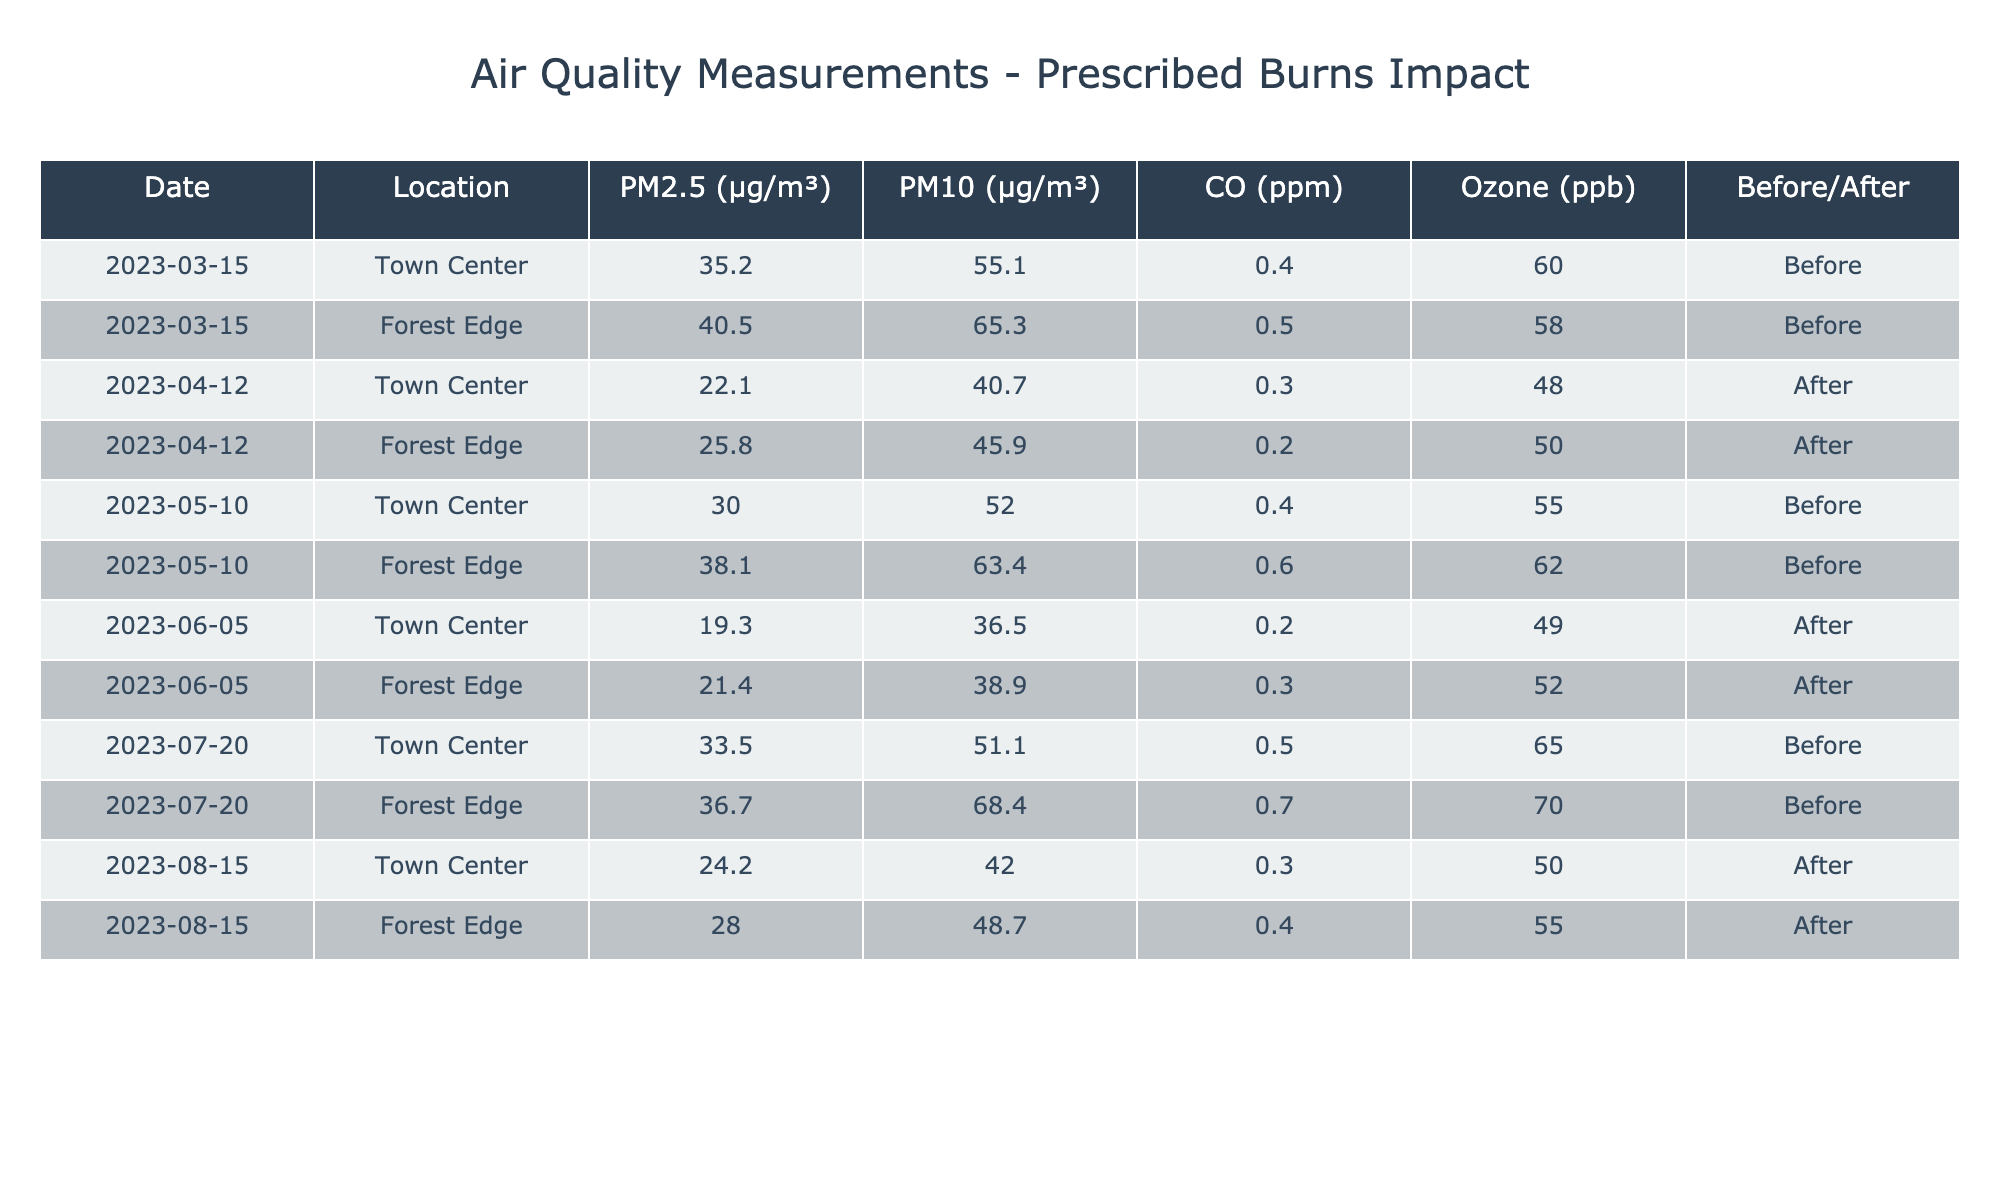What were the PM2.5 levels at Town Center before the first prescribed burn? The PM2.5 level at Town Center on March 15, 2023, before the first burn was 35.2 µg/m³.
Answer: 35.2 µg/m³ What was the highest PM10 measurement recorded in the table? The highest PM10 level recorded was 68.4 µg/m³ at Forest Edge on July 20, 2023, before the burn.
Answer: 68.4 µg/m³ Was the CO level lower after all prescribed burns compared to before? To evaluate this, we compare CO levels before and after. Before the burns, the avg CO was (0.4 + 0.5 + 0.4 + 0.6 + 0.5 + 0.7) / 6 = 0.50 ppm. After the burns, the average CO was (0.3 + 0.2 + 0.3 + 0.4) / 4 = 0.30 ppm. Since 0.30 < 0.50, it indicates that CO levels were lower after all burns.
Answer: Yes What is the average Ozone level at Town Center after the burns? To find the average Ozone after the burns at Town Center: (48 + 49 + 50) / 3 = 49 ppb.
Answer: 49 ppb How much did the PM2.5 levels at Forest Edge decrease after the first burn? The PM2.5 value at Forest Edge before the burn on March 15 was 40.5 µg/m³ and after on April 12 it was 25.8 µg/m³. The decrease is 40.5 - 25.8 = 14.7 µg/m³.
Answer: 14.7 µg/m³ What conclusion can be drawn regarding air quality changes before and after the burns? By comparing average metrics before and after the burns: PM2.5 averages decreased from 33.3 to 21.8 µg/m³, PM10 from 56.3 to 43.5 µg/m³, CO from 0.50 to 0.30 ppm, and Ozone from 55 to 52 ppb. This shows an overall improvement in air quality after the burns.
Answer: Air quality improved after the burns 